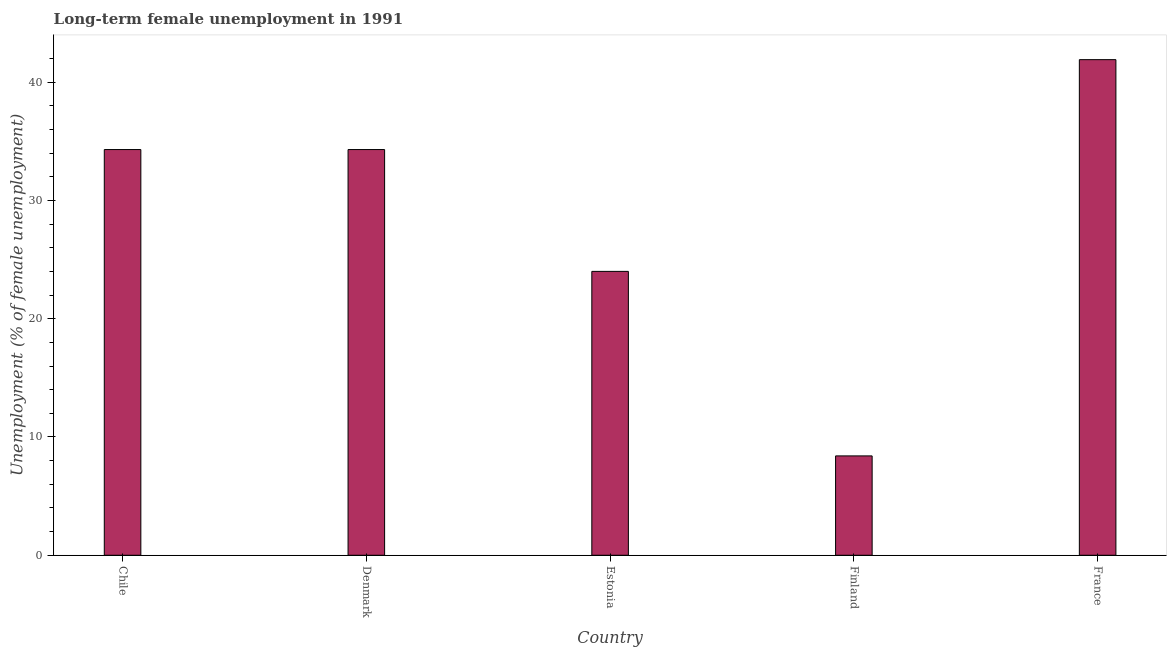What is the title of the graph?
Provide a succinct answer. Long-term female unemployment in 1991. What is the label or title of the Y-axis?
Keep it short and to the point. Unemployment (% of female unemployment). What is the long-term female unemployment in Estonia?
Offer a terse response. 24. Across all countries, what is the maximum long-term female unemployment?
Your answer should be compact. 41.9. Across all countries, what is the minimum long-term female unemployment?
Offer a very short reply. 8.4. In which country was the long-term female unemployment minimum?
Provide a succinct answer. Finland. What is the sum of the long-term female unemployment?
Provide a short and direct response. 142.9. What is the difference between the long-term female unemployment in Finland and France?
Provide a short and direct response. -33.5. What is the average long-term female unemployment per country?
Your response must be concise. 28.58. What is the median long-term female unemployment?
Offer a very short reply. 34.3. In how many countries, is the long-term female unemployment greater than 22 %?
Your answer should be very brief. 4. Is the long-term female unemployment in Estonia less than that in Finland?
Give a very brief answer. No. Is the difference between the long-term female unemployment in Denmark and France greater than the difference between any two countries?
Ensure brevity in your answer.  No. Is the sum of the long-term female unemployment in Denmark and France greater than the maximum long-term female unemployment across all countries?
Provide a succinct answer. Yes. What is the difference between the highest and the lowest long-term female unemployment?
Keep it short and to the point. 33.5. In how many countries, is the long-term female unemployment greater than the average long-term female unemployment taken over all countries?
Give a very brief answer. 3. How many countries are there in the graph?
Make the answer very short. 5. What is the difference between two consecutive major ticks on the Y-axis?
Keep it short and to the point. 10. Are the values on the major ticks of Y-axis written in scientific E-notation?
Provide a short and direct response. No. What is the Unemployment (% of female unemployment) of Chile?
Your answer should be very brief. 34.3. What is the Unemployment (% of female unemployment) in Denmark?
Provide a short and direct response. 34.3. What is the Unemployment (% of female unemployment) of Estonia?
Keep it short and to the point. 24. What is the Unemployment (% of female unemployment) of Finland?
Your answer should be compact. 8.4. What is the Unemployment (% of female unemployment) in France?
Your answer should be very brief. 41.9. What is the difference between the Unemployment (% of female unemployment) in Chile and Finland?
Provide a succinct answer. 25.9. What is the difference between the Unemployment (% of female unemployment) in Chile and France?
Offer a very short reply. -7.6. What is the difference between the Unemployment (% of female unemployment) in Denmark and Finland?
Your answer should be very brief. 25.9. What is the difference between the Unemployment (% of female unemployment) in Denmark and France?
Your answer should be compact. -7.6. What is the difference between the Unemployment (% of female unemployment) in Estonia and Finland?
Offer a very short reply. 15.6. What is the difference between the Unemployment (% of female unemployment) in Estonia and France?
Your answer should be very brief. -17.9. What is the difference between the Unemployment (% of female unemployment) in Finland and France?
Your answer should be compact. -33.5. What is the ratio of the Unemployment (% of female unemployment) in Chile to that in Estonia?
Provide a short and direct response. 1.43. What is the ratio of the Unemployment (% of female unemployment) in Chile to that in Finland?
Provide a short and direct response. 4.08. What is the ratio of the Unemployment (% of female unemployment) in Chile to that in France?
Your answer should be compact. 0.82. What is the ratio of the Unemployment (% of female unemployment) in Denmark to that in Estonia?
Ensure brevity in your answer.  1.43. What is the ratio of the Unemployment (% of female unemployment) in Denmark to that in Finland?
Offer a terse response. 4.08. What is the ratio of the Unemployment (% of female unemployment) in Denmark to that in France?
Give a very brief answer. 0.82. What is the ratio of the Unemployment (% of female unemployment) in Estonia to that in Finland?
Offer a very short reply. 2.86. What is the ratio of the Unemployment (% of female unemployment) in Estonia to that in France?
Keep it short and to the point. 0.57. 